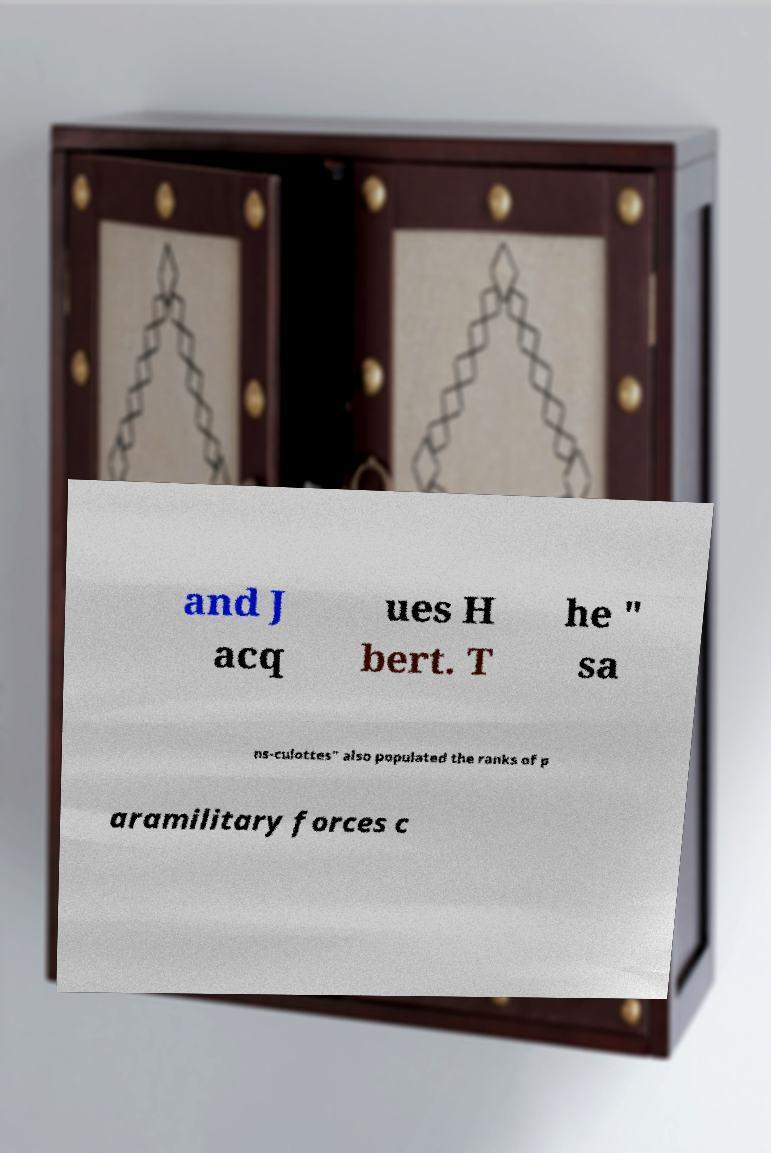For documentation purposes, I need the text within this image transcribed. Could you provide that? and J acq ues H bert. T he " sa ns-culottes" also populated the ranks of p aramilitary forces c 